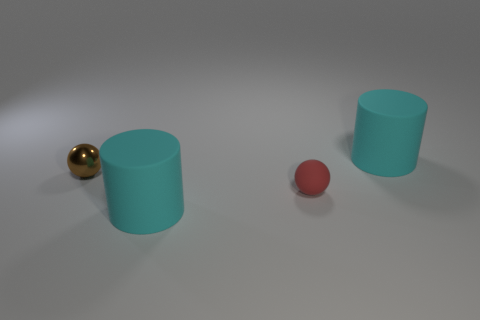Is there any other thing that is made of the same material as the brown sphere?
Offer a very short reply. No. There is a thing that is both behind the matte ball and on the left side of the red matte sphere; what shape is it?
Provide a succinct answer. Sphere. Is there a large cyan sphere?
Ensure brevity in your answer.  No. There is a big matte thing in front of the red object; is there a large cylinder to the right of it?
Give a very brief answer. Yes. What material is the red thing that is the same shape as the tiny brown metal object?
Give a very brief answer. Rubber. Is the number of red spheres greater than the number of spheres?
Make the answer very short. No. There is a thing that is on the left side of the red matte object and right of the metallic object; what is its color?
Ensure brevity in your answer.  Cyan. What number of other objects are the same material as the brown ball?
Ensure brevity in your answer.  0. Is the number of tiny red matte spheres less than the number of large things?
Keep it short and to the point. Yes. Does the tiny red ball have the same material as the cylinder that is in front of the tiny metallic object?
Keep it short and to the point. Yes. 